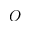<formula> <loc_0><loc_0><loc_500><loc_500>O</formula> 